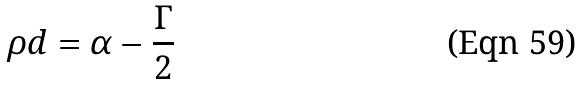Convert formula to latex. <formula><loc_0><loc_0><loc_500><loc_500>\rho d = \alpha - \frac { \Gamma } { 2 }</formula> 